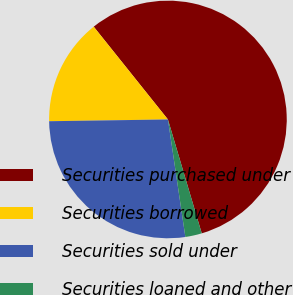Convert chart. <chart><loc_0><loc_0><loc_500><loc_500><pie_chart><fcel>Securities purchased under<fcel>Securities borrowed<fcel>Securities sold under<fcel>Securities loaned and other<nl><fcel>56.15%<fcel>14.5%<fcel>27.11%<fcel>2.25%<nl></chart> 